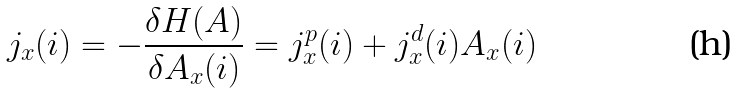<formula> <loc_0><loc_0><loc_500><loc_500>j _ { x } ( i ) = - \frac { \delta H ( A ) } { \delta A _ { x } ( i ) } = j _ { x } ^ { p } ( i ) + j _ { x } ^ { d } ( i ) A _ { x } ( i )</formula> 